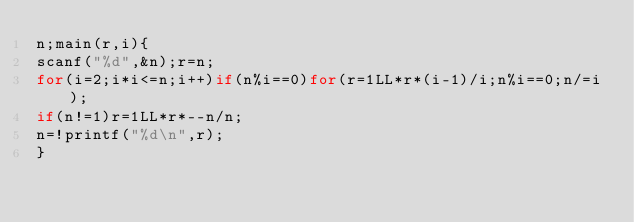Convert code to text. <code><loc_0><loc_0><loc_500><loc_500><_C_>n;main(r,i){
scanf("%d",&n);r=n;
for(i=2;i*i<=n;i++)if(n%i==0)for(r=1LL*r*(i-1)/i;n%i==0;n/=i);
if(n!=1)r=1LL*r*--n/n;
n=!printf("%d\n",r);
}</code> 